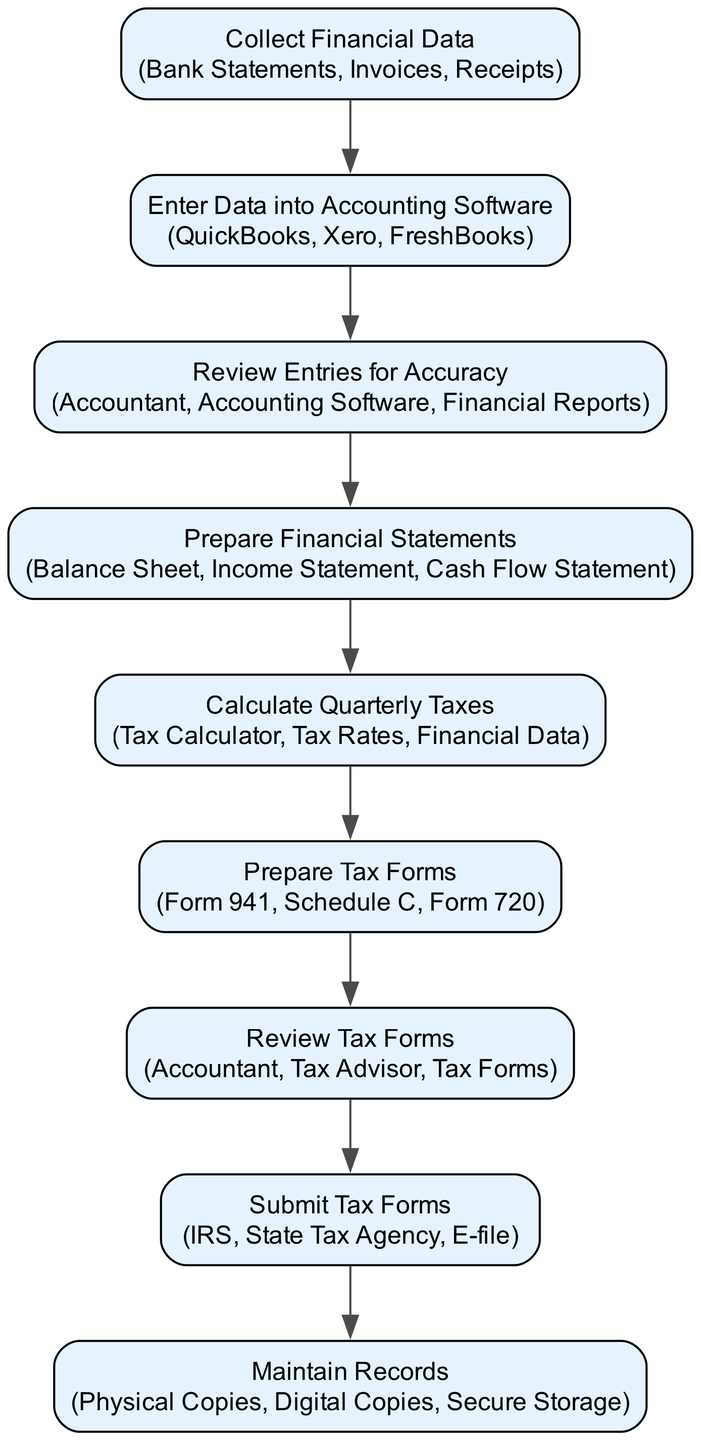What is the first step in the process? The first step in the flow chart is labeled "Collect Financial Data." This can be identified as it is the topmost node in the diagram, with no preceding nodes.
Answer: Collect Financial Data How many steps are there in total? By counting each of the nodes listed in the flow chart, we see that there are eight steps depicted. Each step represents a distinct part of the quarterly tax filing process.
Answer: Eight Which entities are involved in the preparation of tax forms? In reviewing the node labeled "Prepare Tax Forms," we note that the entities listed there are "Form 941, Schedule C, Form 720." These are the required documents noted for this step.
Answer: Form 941, Schedule C, Form 720 What comes after "Review Entries for Accuracy"? The flow from "Review Entries for Accuracy" directly leads to the next step, which is "Prepare Financial Statements." This shows the sequence in the tax filing process.
Answer: Prepare Financial Statements Who is responsible for reviewing the tax forms? In the node "Review Tax Forms," the entities responsible for this action are "Accountant, Tax Advisor." Therefore, these roles are directly indicated as responsible for this review process.
Answer: Accountant, Tax Advisor Which step is related to calculating the tax amount? The step that corresponds with calculating the tax amount is "Calculate Quarterly Taxes." This step specifically addresses the need to determine the tax obligations for the quarter.
Answer: Calculate Quarterly Taxes What is the last step in the process? The last step in the flow chart is "Maintain Records." This can be identified as it is the bottommost node, finalizing the process with the collection of necessary records.
Answer: Maintain Records How does the process flow from preparation of financial statements to tax forms? The flow starts from "Prepare Financial Statements," which is followed by "Calculate Quarterly Taxes." After determining the tax amount, the next step is "Prepare Tax Forms," showing a logical progression from financial preparation to tax filing.
Answer: Prepare Tax Forms 